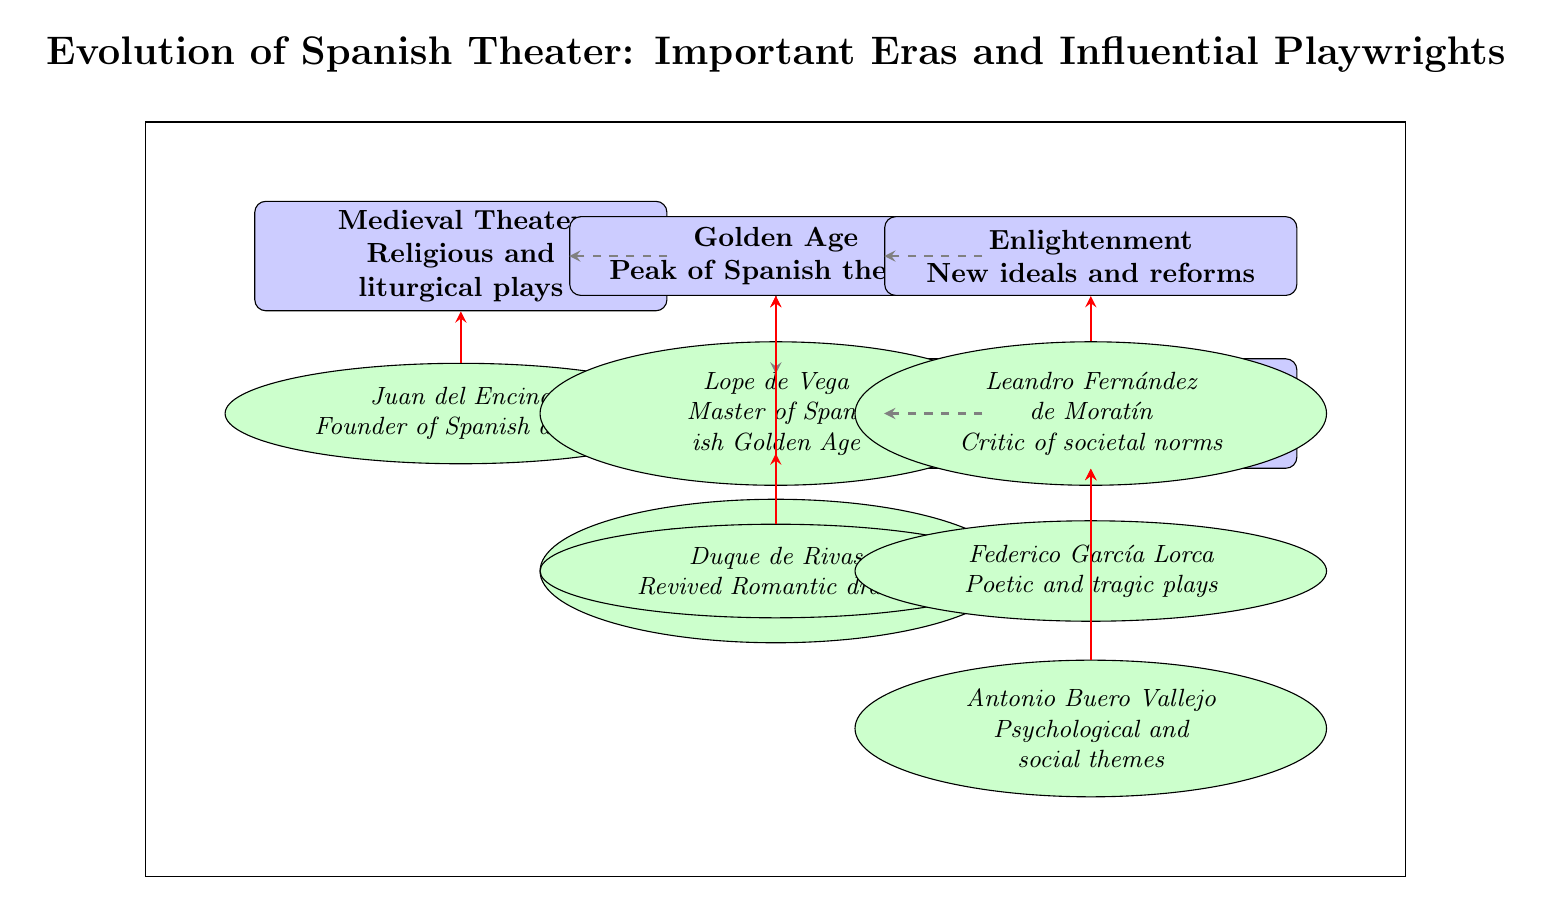What is the first era of Spanish theater depicted in the diagram? The first era in the diagram is labeled as "Medieval Theater", which is positioned at the top left of the diagram. It is the initial rectangle shown.
Answer: Medieval Theater Which playwright is associated with the Golden Age? The diagram indicates two playwrights under the Golden Age: Lope de Vega and Calderón de la Barca. However, since the question is asking for any association, I can mention either as they are both linked to that era. In the diagram, Lope de Vega is shown as below the Golden Age node.
Answer: Lope de Vega How many eras are represented in the diagram? The diagram shows five distinct eras represented by rectangles, from Medieval Theater to Modern Era. To find this, I can simply count the rectangles labeled as eras.
Answer: 5 Which playwright is noted as the founder of Spanish drama? The diagram clearly indicates Juan del Encina below the Medieval Theater node with a note stating he is the "Founder of Spanish drama." Thus, by looking at the playwrights associated with each era, it is straightforward to identify him under Medieval Theater.
Answer: Juan del Encina Which era comes directly after Romanticism in the diagram? By examining the directional transitions in the diagram, I see an arrow pointing from Romanticism to Modern Era, meaning that Modern Era is the next era that follows it. This can be confirmed by looking at the specific arrangement of the nodes.
Answer: Modern Era Who is described as a critic of societal norms? Leandro Fernández de Moratín is placed under the Enlightenment era in the diagram, with a description stating he is a "Critic of societal norms." This information can be extracted by observing the playwright's label associated with that specific era.
Answer: Leandro Fernández de Moratín What is the relationship between Romanticism and Modern Era based on the diagram? The diagram has a dashed arrow labeled as "transition" pointing from Romanticism to Modern Era, which indicates a direct relationship indicating progression or development from Romanticism to the subsequent Modern Era. Hence, the connection can be seen visually.
Answer: Transition Which playwright signifies a revival of Romantic drama? The playwright Duque de Rivas is listed below the Romanticism era in the diagram with a note stating "Revived Romantic drama." Identifying his association visually shows his role connected to that specific period.
Answer: Duque de Rivas How are the influences of playwrights illustrated in the diagram? The influences are shown with solid red arrows pointing from each playwright to their respective era, indicating a direct relationship where the playwrights have impacted or shaped the characteristics of their corresponding eras. Recognizing these arrows clarifies the flow of influence.
Answer: By solid red arrows 